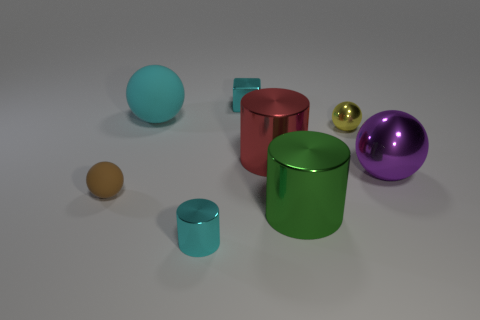Which object appears to be the largest in the image? The large purple sphere seems to be the largest object within the assortment of shapes presented in the image. 